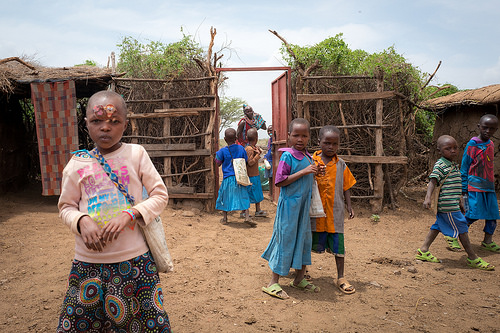<image>
Can you confirm if the sandal is on the boy? Yes. Looking at the image, I can see the sandal is positioned on top of the boy, with the boy providing support. 